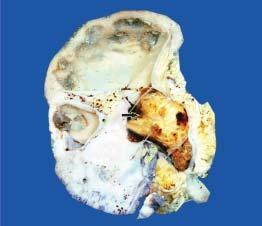s thalassaemia and hbd enlarged and heavy?
Answer the question using a single word or phrase. No 